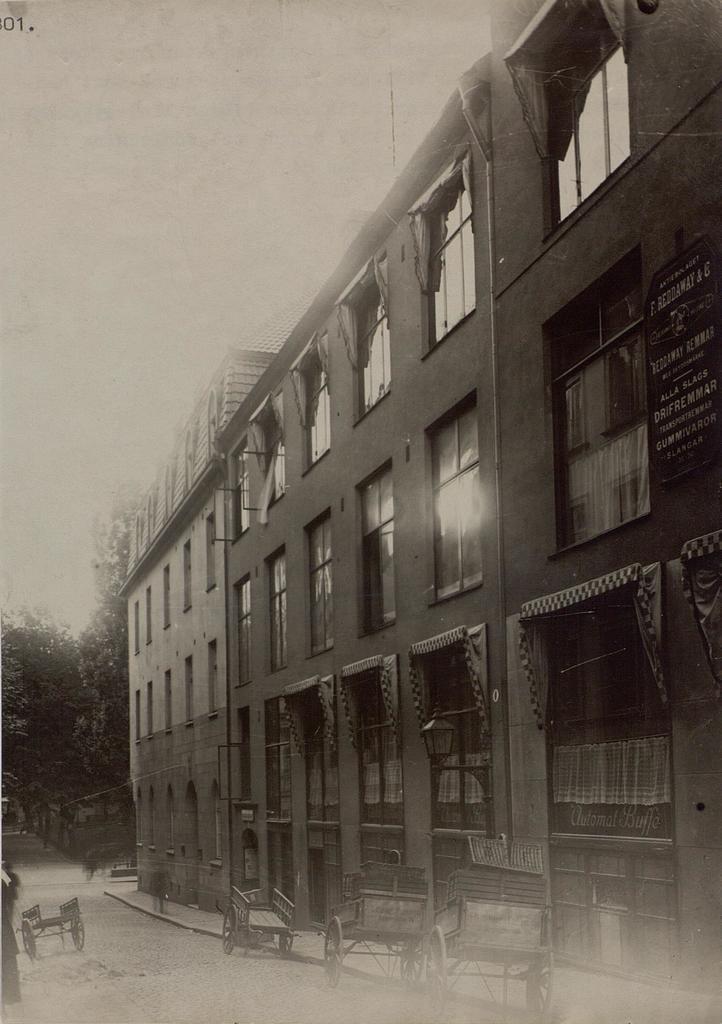Could you give a brief overview of what you see in this image? In this image I can see few carts, building, number of windows, a board, few trees and I can see something is written on this board. I can also see this image is black and white in colour. 